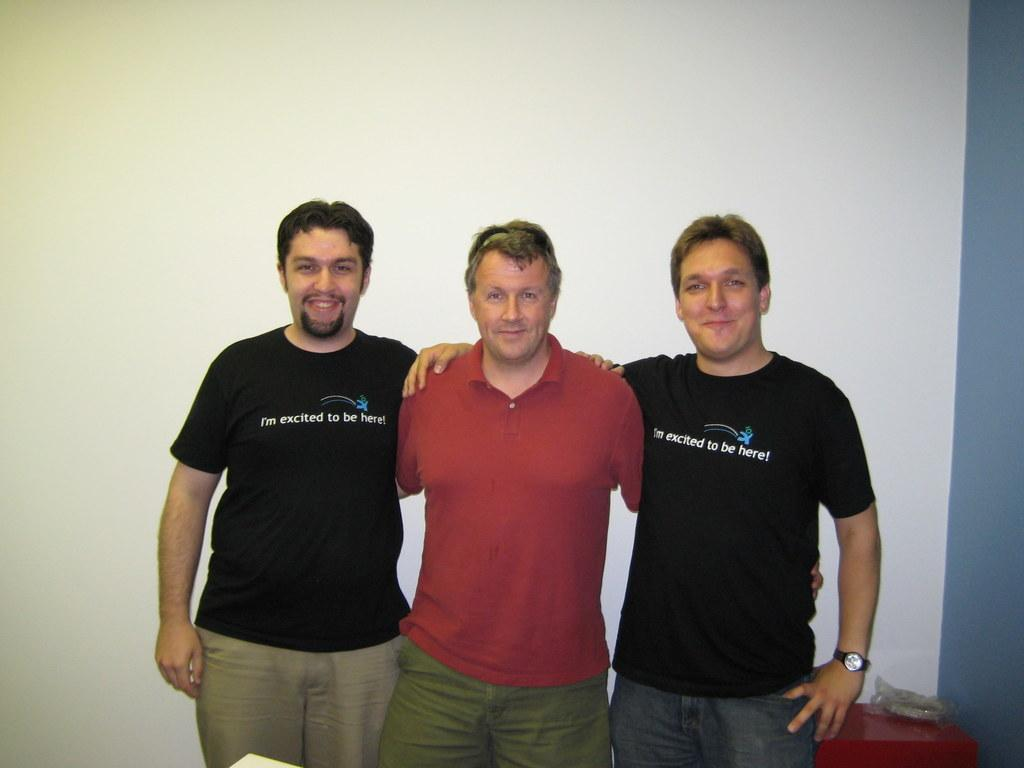How many people are in the image? There are three friends in the image. What are the friends doing in the image? The friends are standing and smiling. What might be the reason for their poses in the image? The friends are posing for the camera. What can be seen in the background of the image? There is a white color wall in the background of the image. What type of farming equipment can be seen in the hands of the friends in the image? There is no farming equipment present in the image; the friends are not holding any tools or equipment related to farming. 